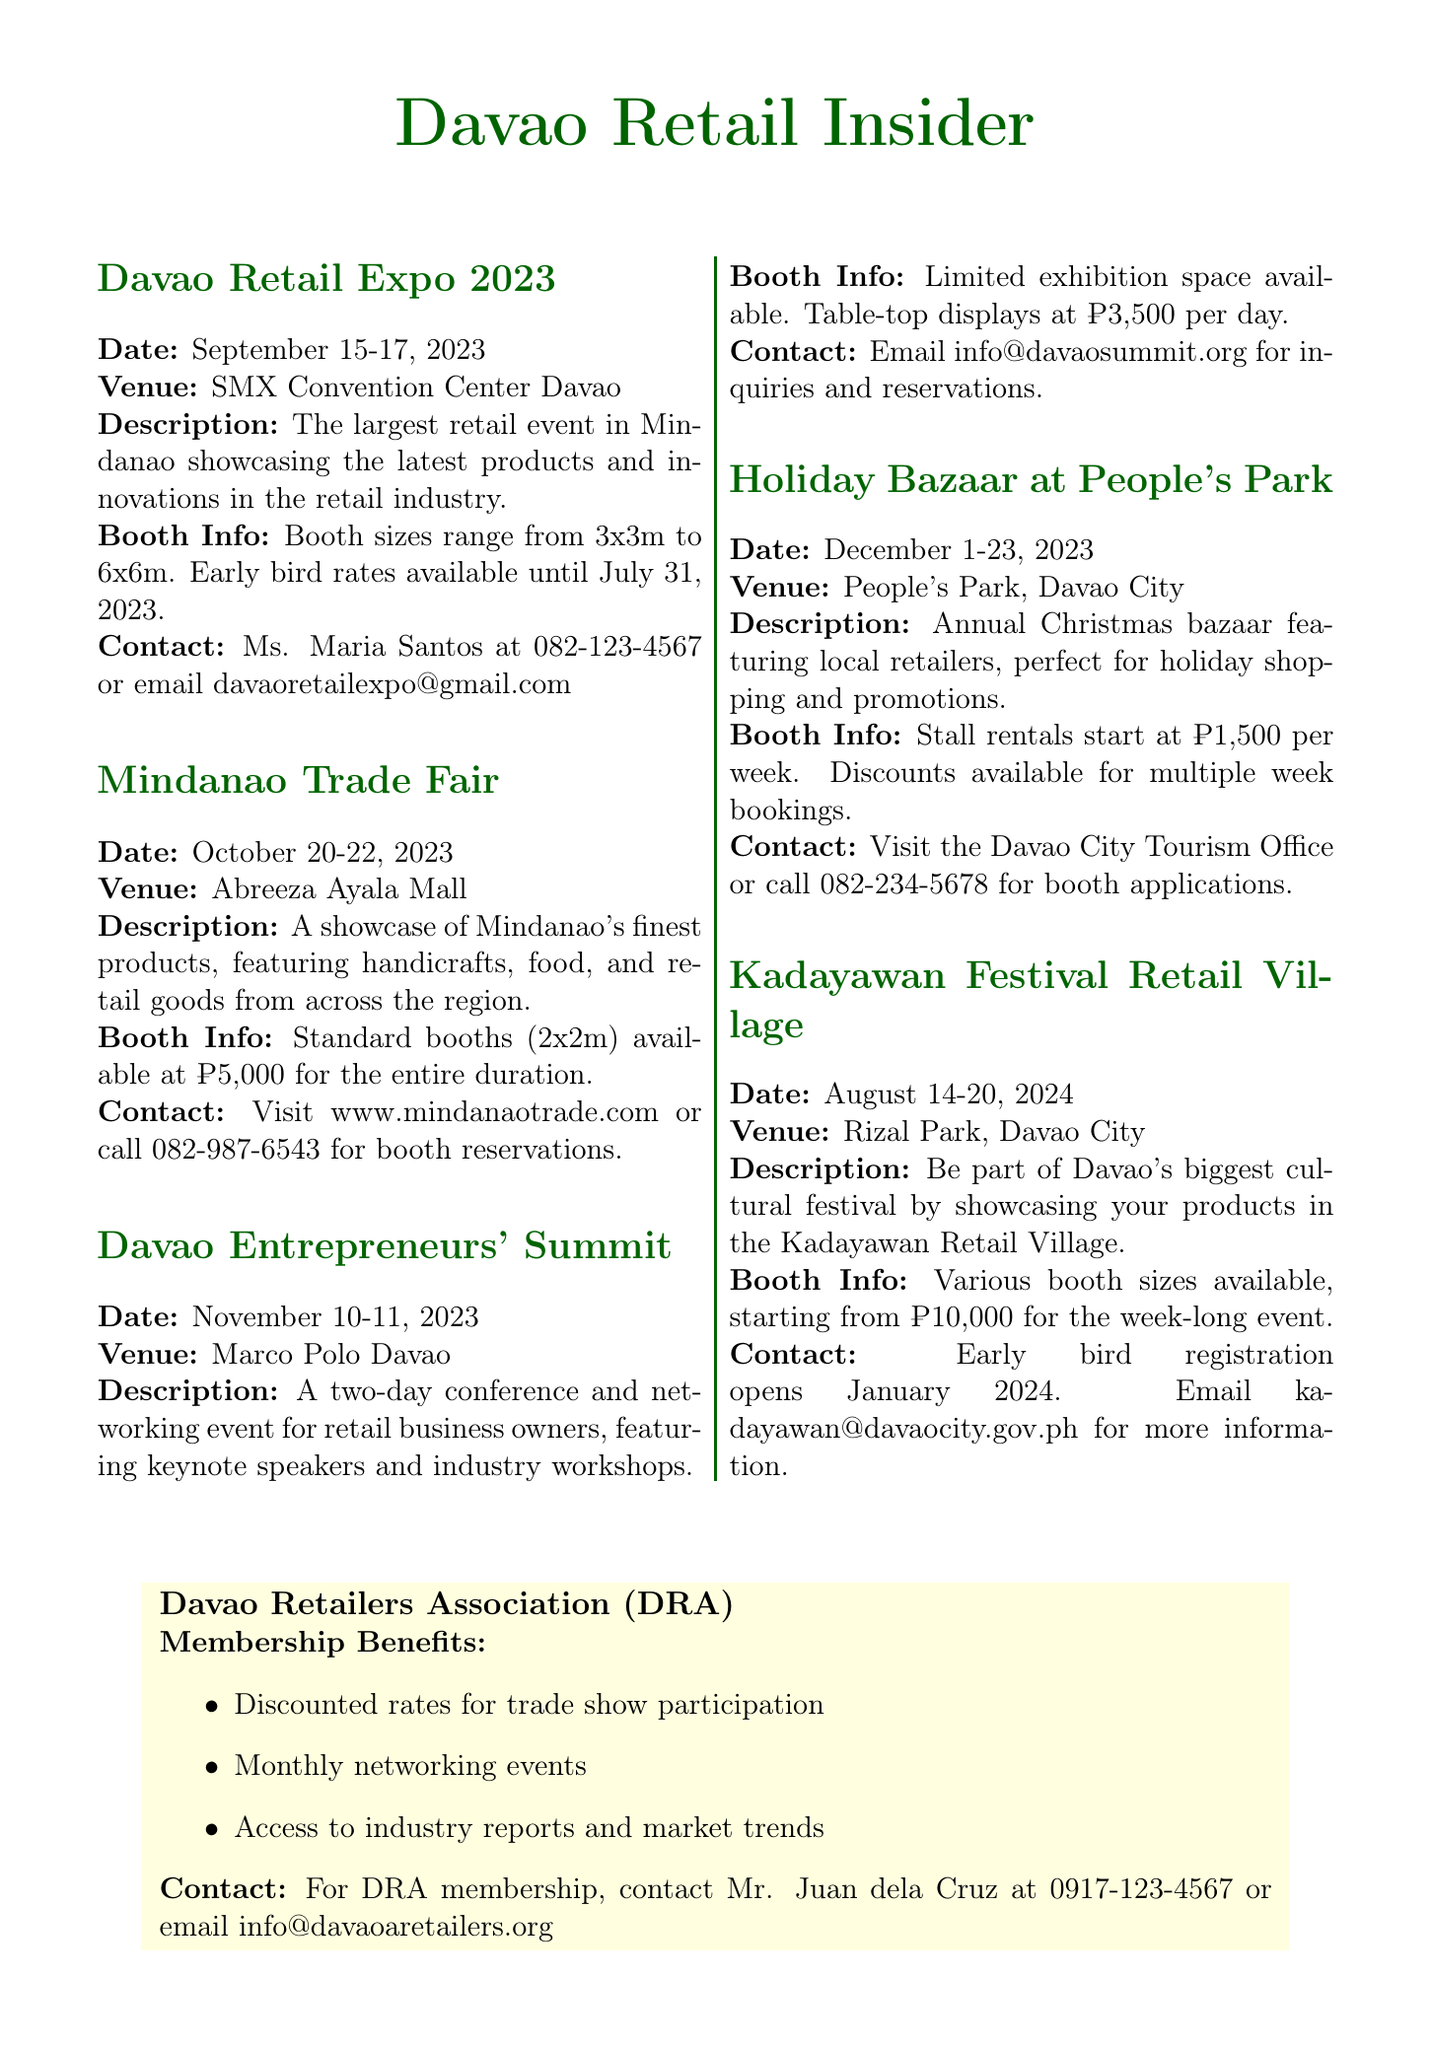What are the dates for the Davao Retail Expo 2023? The dates are specifically mentioned under the Davao Retail Expo section of the newsletter.
Answer: September 15-17, 2023 What is the venue for the Mindanao Trade Fair? The venue information is provided in the Mindanao Trade Fair section of the newsletter.
Answer: Abreeza Ayala Mall How much does a standard booth cost at the Mindanao Trade Fair? The cost for booths is specified in the booth information for the Mindanao Trade Fair section.
Answer: ₱5,000 Who should be contacted for booth reservations for the Davao Entrepreneurs' Summit? The contact information is listed in the Davao Entrepreneurs' Summit section of the newsletter.
Answer: info@davaosummit.org What is the duration of the Holiday Bazaar at People's Park? The duration is mentioned in the Holiday Bazaar section of the newsletter.
Answer: December 1-23, 2023 What type of exhibition space is available at the Davao Entrepreneurs' Summit? The exhibition space details are found in the Davao Entrepreneurs' Summit booth information.
Answer: Limited exhibition space What are the benefits of joining the Davao Retailers Association? The newsletter outlines specific benefits in the additional info section about DRA membership.
Answer: Discounted rates for trade show participation When does early bird registration open for the Kadayawan Festival Retail Village? The registration timeframe is noted in the Kadayawan Festival Retail Village section.
Answer: January 2024 What is the cost of stall rentals per week for the Holiday Bazaar? The stall rental pricing is provided in the booth information for the Holiday Bazaar.
Answer: ₱1,500 